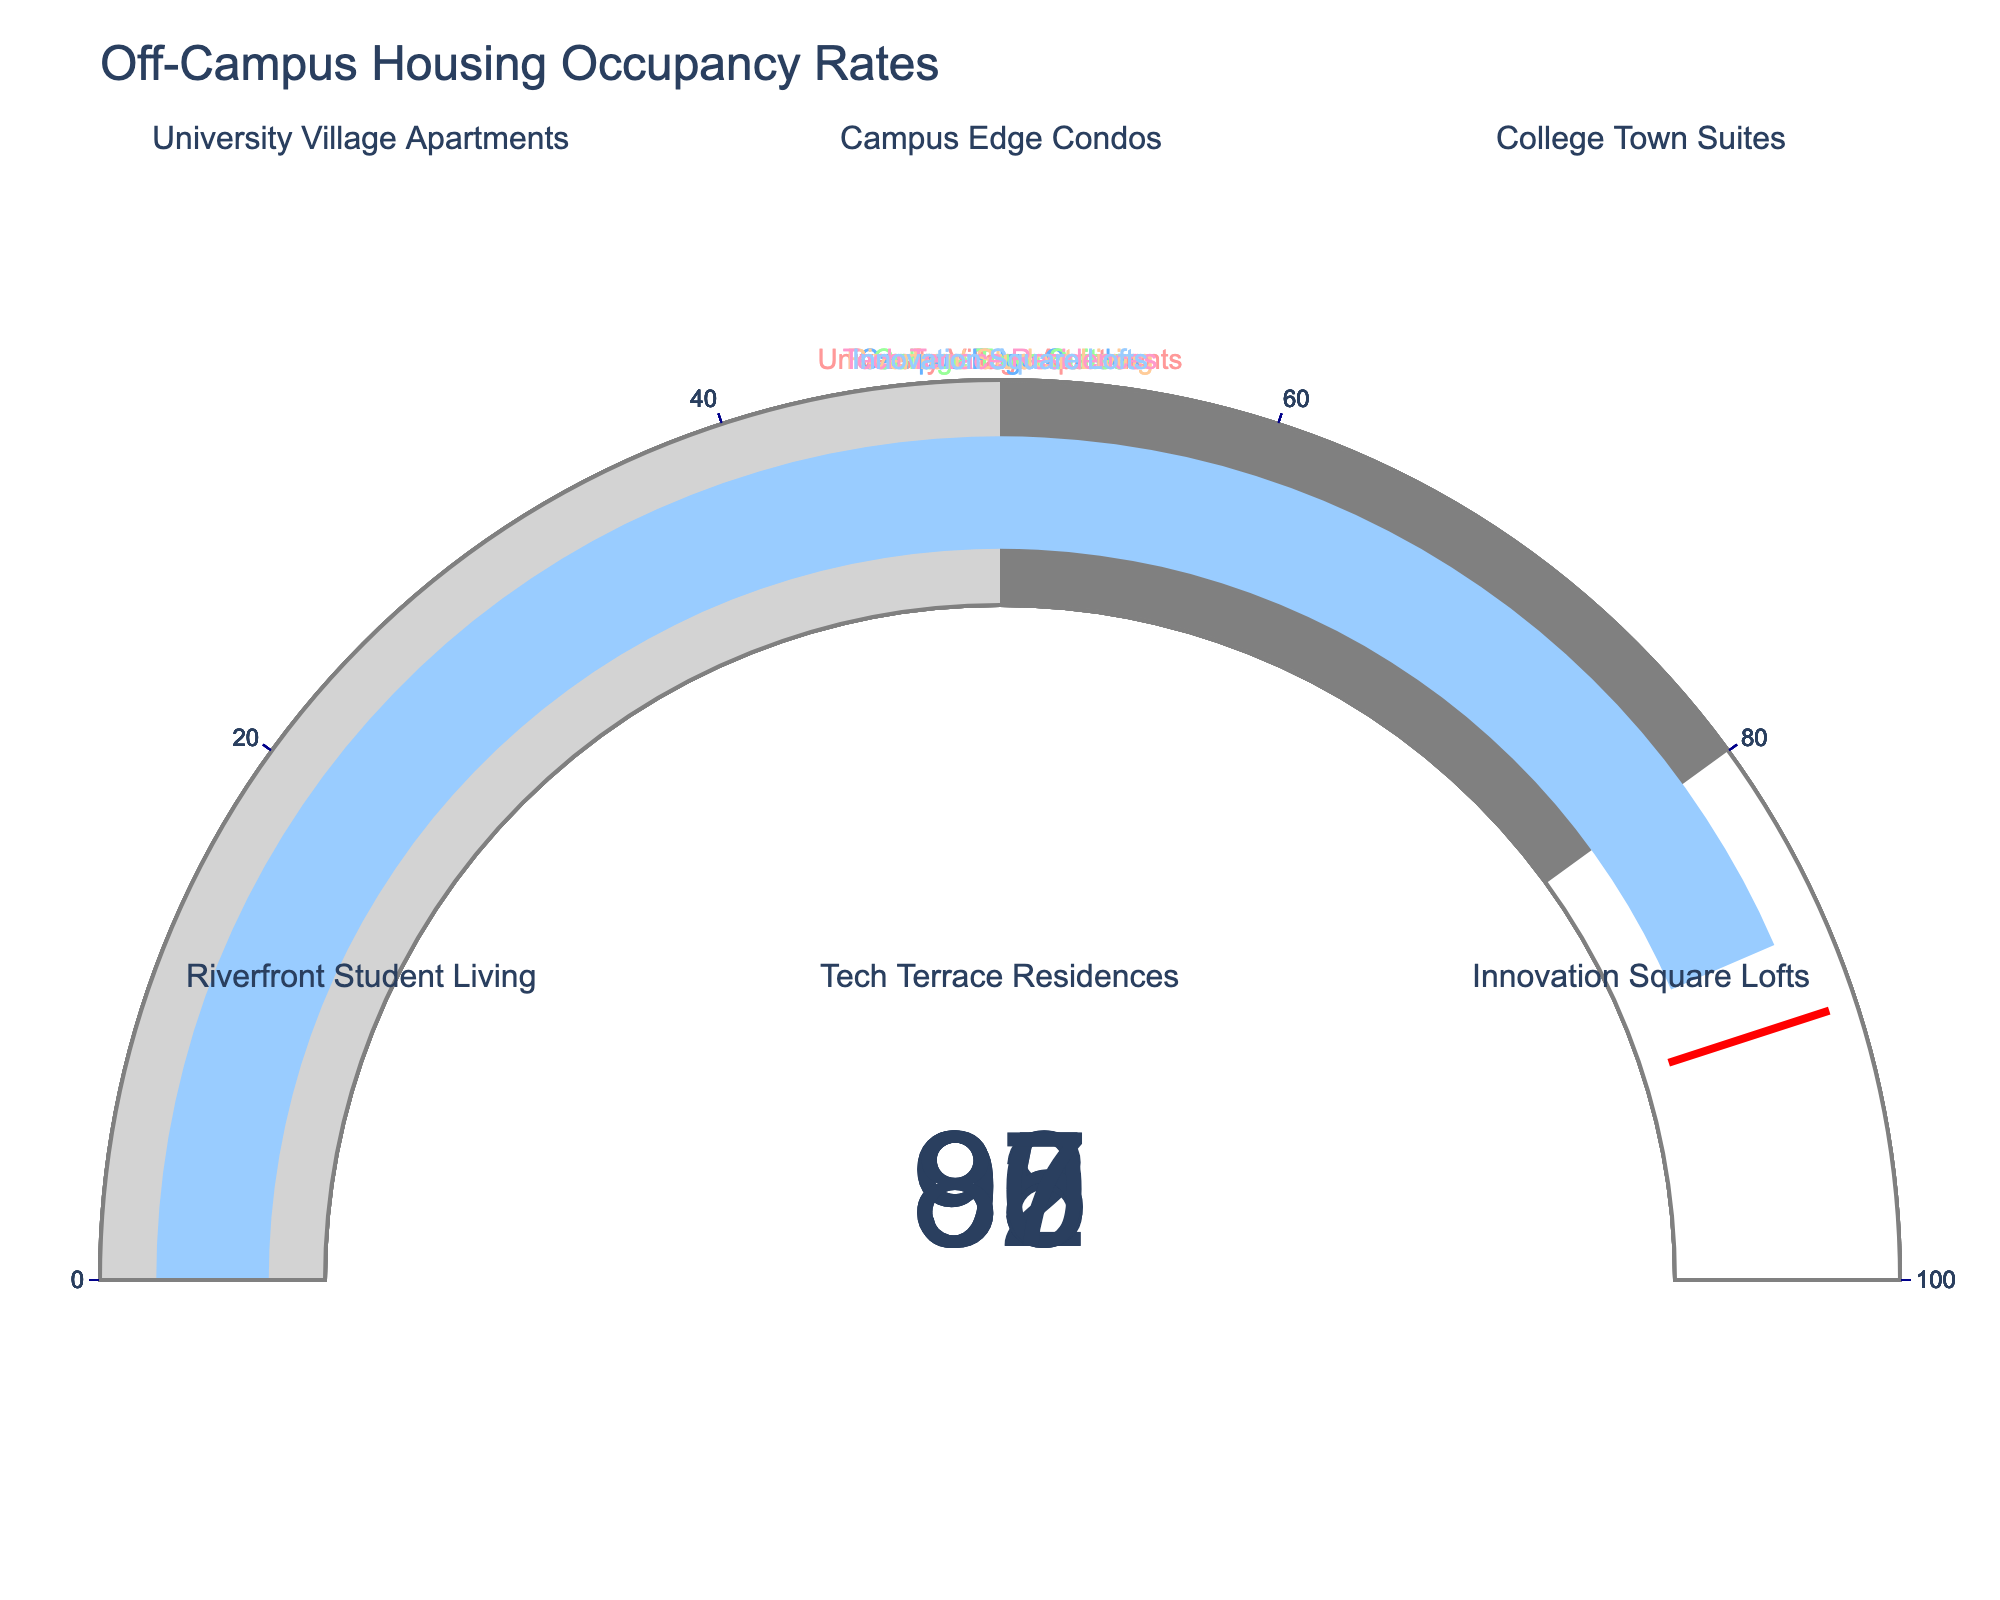Which off-campus housing option has the highest occupancy rate? We need to look for the gauge with the highest value. The occupancy rates shown are: 92, 88, 95, 85, 90, and 87. The highest value is 95, which is for College Town Suites.
Answer: College Town Suites What is the median occupancy rate among all the housing options? First, list all the occupancy rates: 92, 88, 95, 85, 90, and 87. Next, sort them in ascending order: 85, 87, 88, 90, 92, 95. The median is the average of the middle two numbers, which are 88 and 90, thus (88+90) / 2 = 89.
Answer: 89 Which housing options have occupancy rates lower than the threshold value (90) indicated in the gauge charts? Housing options with rates lower than 90 are: Campus Edge Condos (88), Riverfront Student Living (85), and Innovation Square Lofts (87).
Answer: Campus Edge Condos, Riverfront Student Living, Innovation Square Lofts Is the occupancy rate of Tech Terrace Residences above or below the median occupancy rate? The occupancy rate of Tech Terrace Residences is 90. As calculated earlier, the median occupancy rate is 89. Therefore, Tech Terrace Residences has an occupancy rate above the median.
Answer: Above What is the total occupancy rate of all the housing options combined? Add all occupancy rates together: 92 + 88 + 95 + 85 + 90 + 87 = 537.
Answer: 537 Among the options with occupancy rates below 90, which one has the highest rate? Consider the occupancy rates below 90: 88, 85, and 87. The highest among them is 88, which is for Campus Edge Condos.
Answer: Campus Edge Condos 